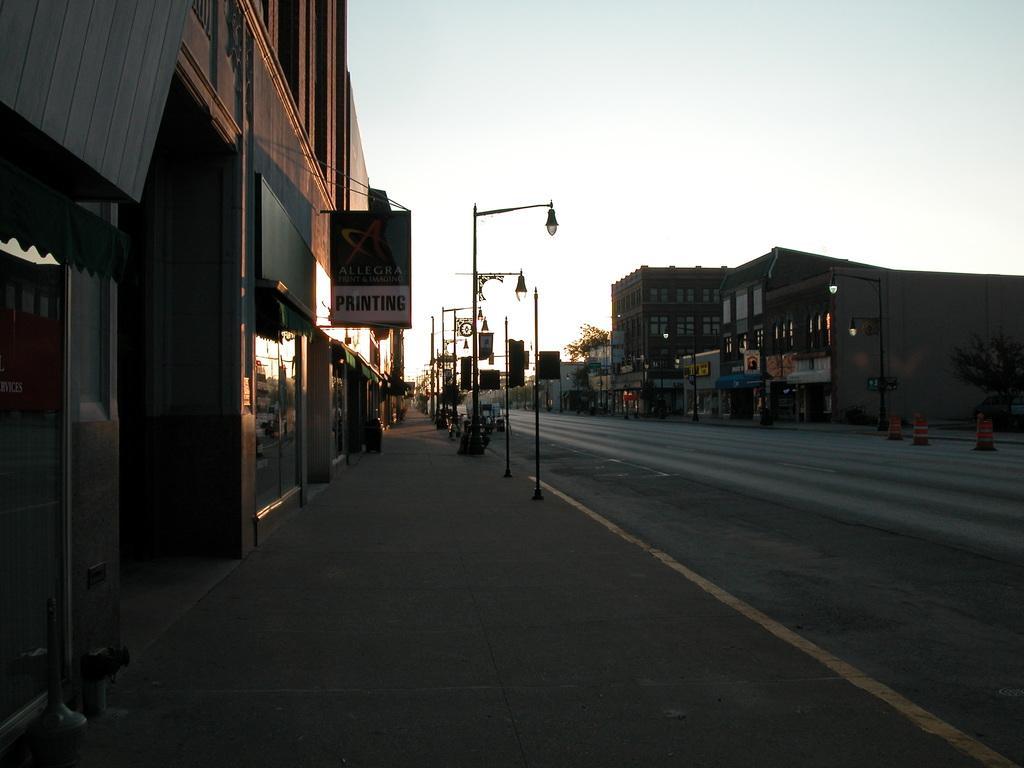Please provide a concise description of this image. In the center of the image we can see the sky, buildings, poles, lamps, lights, sign boards, traffic poles and a few other objects. 